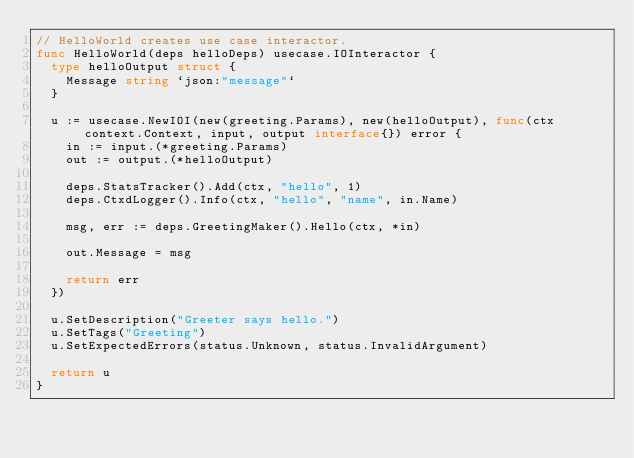<code> <loc_0><loc_0><loc_500><loc_500><_Go_>// HelloWorld creates use case interactor.
func HelloWorld(deps helloDeps) usecase.IOInteractor {
	type helloOutput struct {
		Message string `json:"message"`
	}

	u := usecase.NewIOI(new(greeting.Params), new(helloOutput), func(ctx context.Context, input, output interface{}) error {
		in := input.(*greeting.Params)
		out := output.(*helloOutput)

		deps.StatsTracker().Add(ctx, "hello", 1)
		deps.CtxdLogger().Info(ctx, "hello", "name", in.Name)

		msg, err := deps.GreetingMaker().Hello(ctx, *in)

		out.Message = msg

		return err
	})

	u.SetDescription("Greeter says hello.")
	u.SetTags("Greeting")
	u.SetExpectedErrors(status.Unknown, status.InvalidArgument)

	return u
}
</code> 